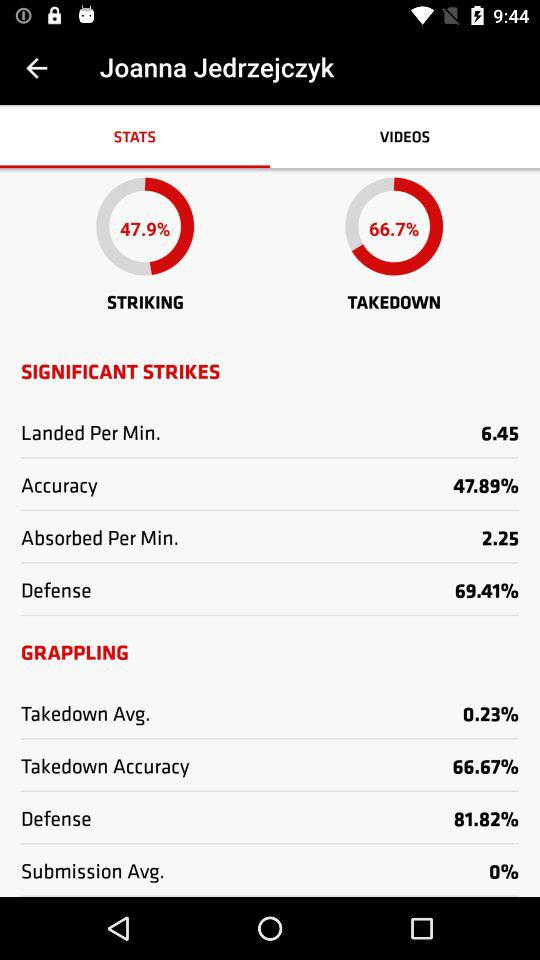What is the percentage of defence in "GRAPPLING"? The percentage of defence is 81.82. 